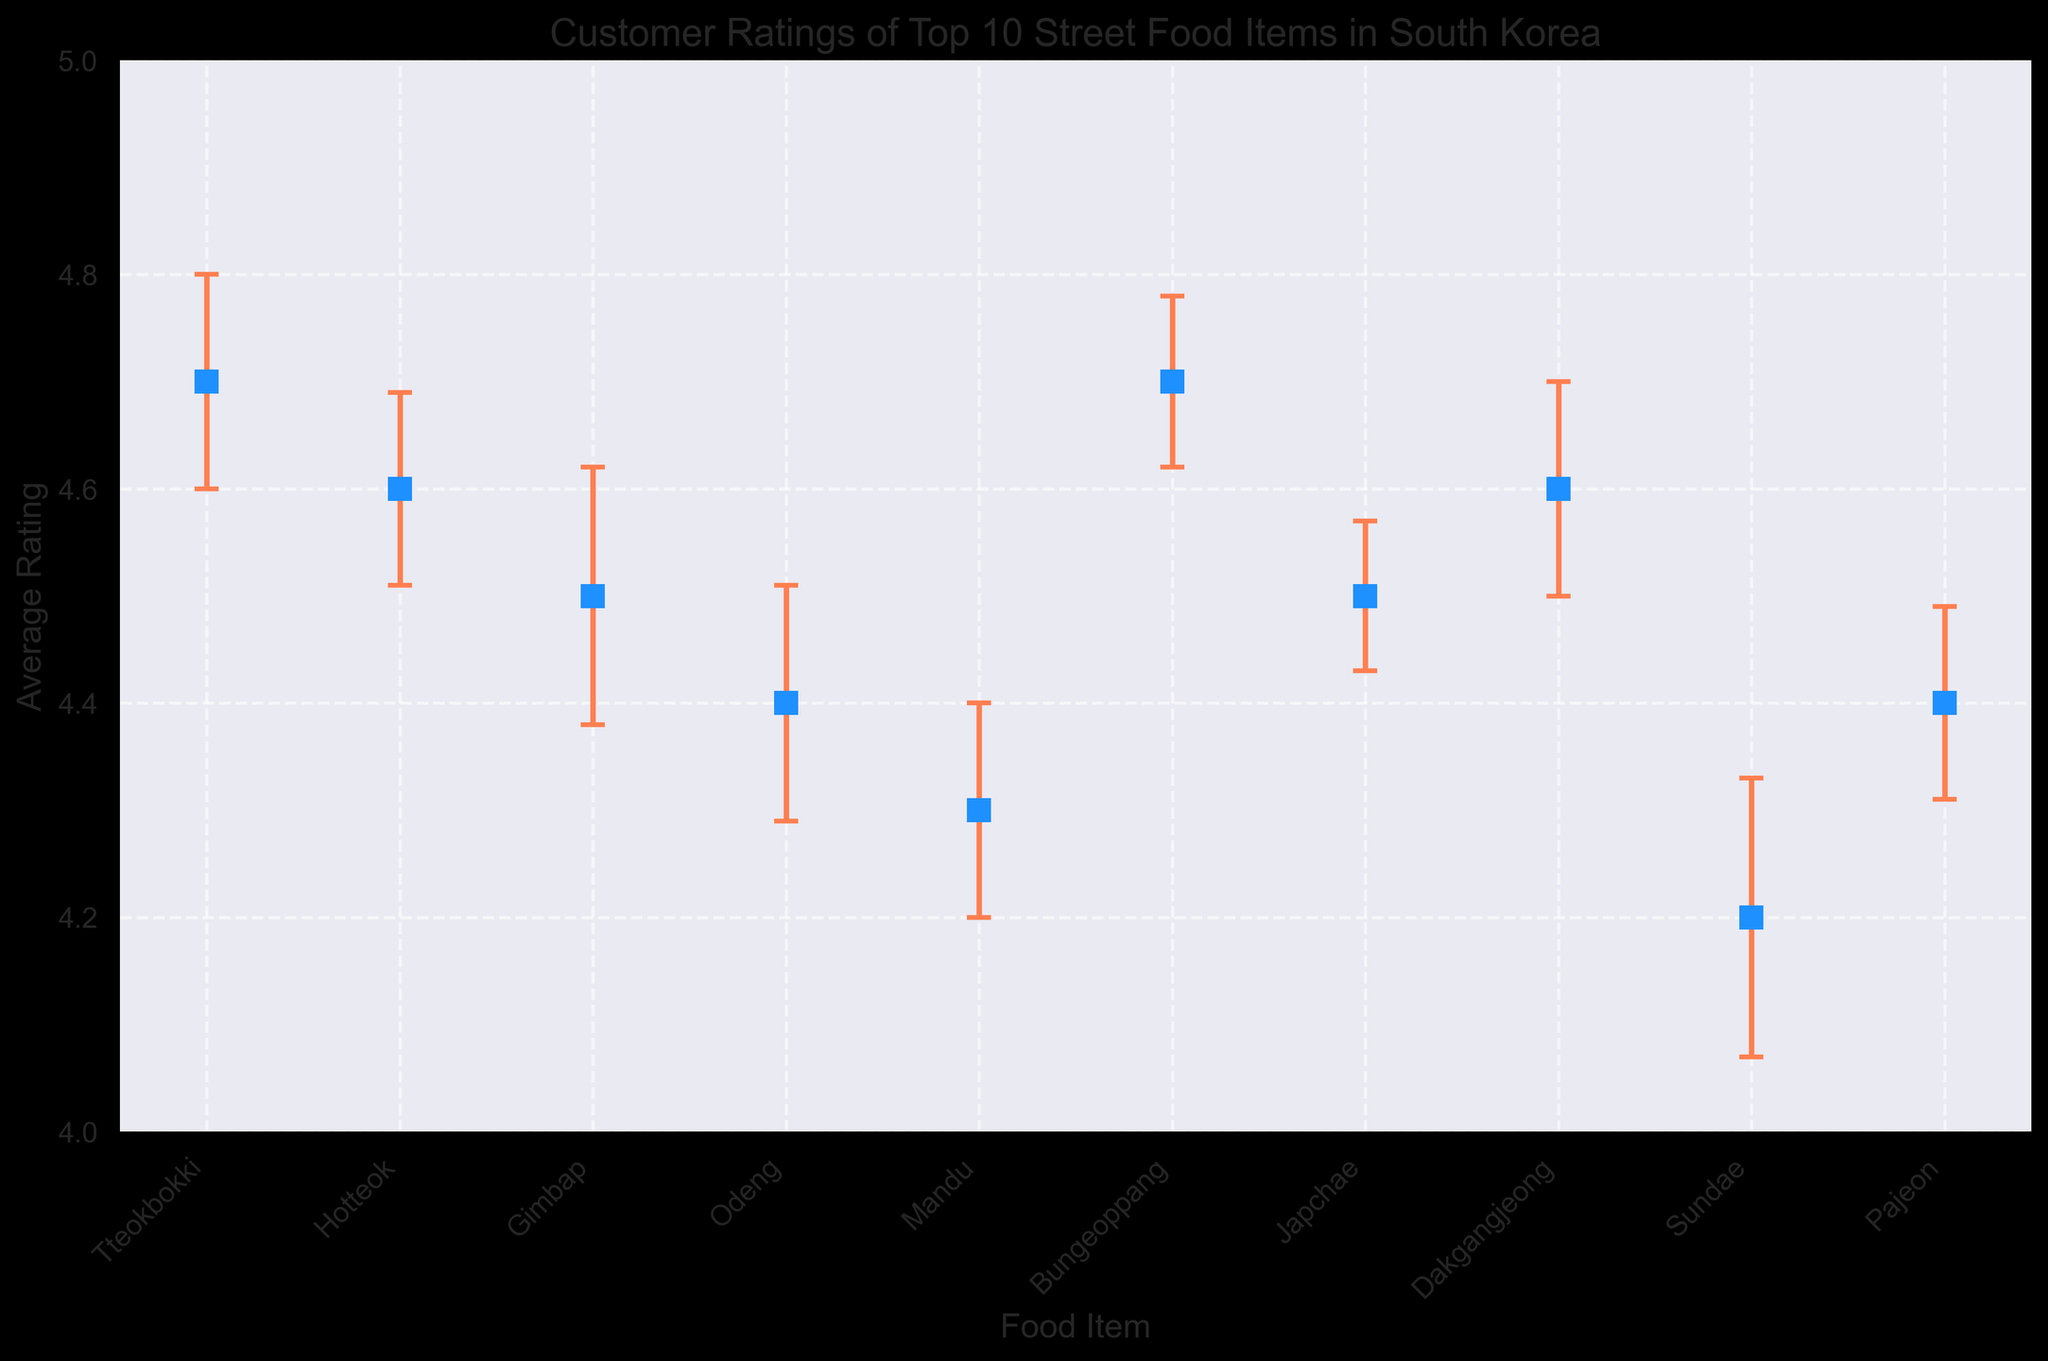Which food item has the highest average rating? Tteokbokki and Bungeoppang both have an average rating of 4.7, which is the highest among the listed items.
Answer: Tteokbokki and Bungeoppang Which food item has the lowest average rating? Sundae has an average rating of 4.2, which is the lowest among the listed items.
Answer: Sundae What is the average rating difference between Tteokbokki and Odeng? The average rating of Tteokbokki is 4.7, while the average rating of Odeng is 4.4. The difference is 4.7 - 4.4 = 0.3.
Answer: 0.3 Which food item has the largest error bar (representing the highest uncertainty in the rating)? Sundae has the largest error bar with a standard error of 0.13, indicating the highest uncertainty in its rating.
Answer: Sundae How many food items have an average rating equal to or above 4.5? Tteokbokki, Hotteok, Gimbap, Bungeoppang, Japchae, and Dakgangjeong all have average ratings equal to or above 4.5. This makes a total of 6 items.
Answer: 6 What is the approximate visual difference in average rating between the highest and lowest rated food items? The highest rated items (Tteokbokki and Bungeoppang) have an average rating of 4.7, and the lowest rated item (Sundae) has an average rating of 4.2. The visual difference is approximately 4.7 - 4.2 = 0.5.
Answer: 0.5 Which food items have error bars that overlap with each other? The error bars of Tteokbokki (4.7 ± 0.1) and Hotteok (4.6 ± 0.09) overlap, as well as Tteokbokki and Bungeoppang (4.7 ± 0.08). Similarly, the error bars of Hotteok and Dakgangjeong (4.6 ± 0.1), Gimbap (4.5 ± 0.12) and Japchae (4.5 ± 0.07), and Odeng (4.4 ± 0.11) and Pajeon (4.4 ± 0.09) overlap.
Answer: Multiple pairs What is the median average rating of all the food items? To find the median, list the average ratings in ascending order: 4.2, 4.3, 4.4, 4.4, 4.5, 4.5, 4.6, 4.6, 4.7, 4.7. The median of these values is the average of the 5th and 6th values: (4.5 + 4.5) / 2 = 4.5.
Answer: 4.5 Which has a larger average rating, Mandu or Pajeon? The average rating of Mandu is 4.3 and that of Pajeon is 4.4. Therefore, Pajeon has a larger average rating.
Answer: Pajeon What does a larger error bar indicate about a food item's rating? A larger error bar indicates greater uncertainty or variability in the customer ratings for that food item.
Answer: Greater uncertainty 